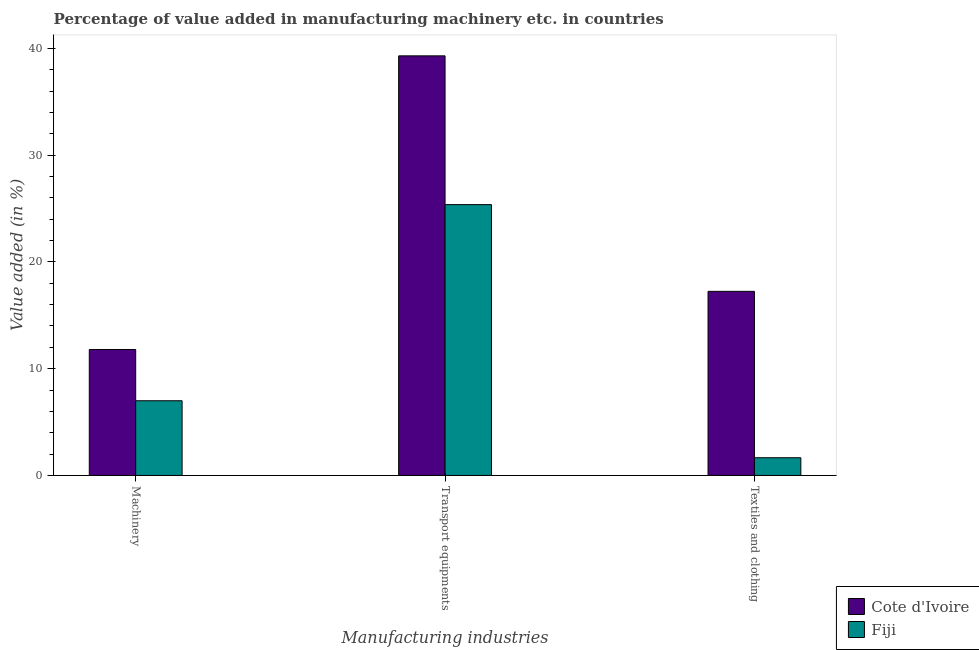Are the number of bars per tick equal to the number of legend labels?
Make the answer very short. Yes. Are the number of bars on each tick of the X-axis equal?
Your response must be concise. Yes. How many bars are there on the 2nd tick from the right?
Your answer should be very brief. 2. What is the label of the 2nd group of bars from the left?
Provide a succinct answer. Transport equipments. What is the value added in manufacturing transport equipments in Fiji?
Your response must be concise. 25.37. Across all countries, what is the maximum value added in manufacturing transport equipments?
Provide a short and direct response. 39.31. Across all countries, what is the minimum value added in manufacturing machinery?
Provide a short and direct response. 7. In which country was the value added in manufacturing textile and clothing maximum?
Give a very brief answer. Cote d'Ivoire. In which country was the value added in manufacturing machinery minimum?
Ensure brevity in your answer.  Fiji. What is the total value added in manufacturing transport equipments in the graph?
Give a very brief answer. 64.67. What is the difference between the value added in manufacturing textile and clothing in Fiji and that in Cote d'Ivoire?
Your answer should be very brief. -15.59. What is the difference between the value added in manufacturing machinery in Cote d'Ivoire and the value added in manufacturing transport equipments in Fiji?
Offer a very short reply. -13.57. What is the average value added in manufacturing transport equipments per country?
Make the answer very short. 32.34. What is the difference between the value added in manufacturing textile and clothing and value added in manufacturing transport equipments in Fiji?
Your answer should be very brief. -23.71. What is the ratio of the value added in manufacturing transport equipments in Cote d'Ivoire to that in Fiji?
Your response must be concise. 1.55. Is the value added in manufacturing transport equipments in Fiji less than that in Cote d'Ivoire?
Keep it short and to the point. Yes. What is the difference between the highest and the second highest value added in manufacturing textile and clothing?
Your answer should be compact. 15.59. What is the difference between the highest and the lowest value added in manufacturing transport equipments?
Ensure brevity in your answer.  13.94. In how many countries, is the value added in manufacturing textile and clothing greater than the average value added in manufacturing textile and clothing taken over all countries?
Offer a terse response. 1. What does the 2nd bar from the left in Transport equipments represents?
Your response must be concise. Fiji. What does the 2nd bar from the right in Machinery represents?
Your answer should be compact. Cote d'Ivoire. Is it the case that in every country, the sum of the value added in manufacturing machinery and value added in manufacturing transport equipments is greater than the value added in manufacturing textile and clothing?
Give a very brief answer. Yes. How many bars are there?
Your response must be concise. 6. Are all the bars in the graph horizontal?
Your answer should be very brief. No. How many countries are there in the graph?
Your answer should be compact. 2. Are the values on the major ticks of Y-axis written in scientific E-notation?
Your answer should be very brief. No. Does the graph contain any zero values?
Offer a very short reply. No. Where does the legend appear in the graph?
Ensure brevity in your answer.  Bottom right. How are the legend labels stacked?
Offer a very short reply. Vertical. What is the title of the graph?
Provide a short and direct response. Percentage of value added in manufacturing machinery etc. in countries. Does "Other small states" appear as one of the legend labels in the graph?
Offer a very short reply. No. What is the label or title of the X-axis?
Make the answer very short. Manufacturing industries. What is the label or title of the Y-axis?
Offer a terse response. Value added (in %). What is the Value added (in %) of Cote d'Ivoire in Machinery?
Provide a short and direct response. 11.8. What is the Value added (in %) of Fiji in Machinery?
Make the answer very short. 7. What is the Value added (in %) in Cote d'Ivoire in Transport equipments?
Provide a short and direct response. 39.31. What is the Value added (in %) of Fiji in Transport equipments?
Give a very brief answer. 25.37. What is the Value added (in %) of Cote d'Ivoire in Textiles and clothing?
Your answer should be very brief. 17.25. What is the Value added (in %) of Fiji in Textiles and clothing?
Your answer should be very brief. 1.66. Across all Manufacturing industries, what is the maximum Value added (in %) in Cote d'Ivoire?
Make the answer very short. 39.31. Across all Manufacturing industries, what is the maximum Value added (in %) in Fiji?
Make the answer very short. 25.37. Across all Manufacturing industries, what is the minimum Value added (in %) of Cote d'Ivoire?
Your response must be concise. 11.8. Across all Manufacturing industries, what is the minimum Value added (in %) in Fiji?
Make the answer very short. 1.66. What is the total Value added (in %) of Cote d'Ivoire in the graph?
Ensure brevity in your answer.  68.35. What is the total Value added (in %) of Fiji in the graph?
Give a very brief answer. 34.02. What is the difference between the Value added (in %) in Cote d'Ivoire in Machinery and that in Transport equipments?
Ensure brevity in your answer.  -27.51. What is the difference between the Value added (in %) in Fiji in Machinery and that in Transport equipments?
Offer a terse response. -18.37. What is the difference between the Value added (in %) in Cote d'Ivoire in Machinery and that in Textiles and clothing?
Offer a very short reply. -5.45. What is the difference between the Value added (in %) of Fiji in Machinery and that in Textiles and clothing?
Your answer should be compact. 5.34. What is the difference between the Value added (in %) in Cote d'Ivoire in Transport equipments and that in Textiles and clothing?
Offer a very short reply. 22.06. What is the difference between the Value added (in %) of Fiji in Transport equipments and that in Textiles and clothing?
Provide a short and direct response. 23.71. What is the difference between the Value added (in %) in Cote d'Ivoire in Machinery and the Value added (in %) in Fiji in Transport equipments?
Keep it short and to the point. -13.57. What is the difference between the Value added (in %) of Cote d'Ivoire in Machinery and the Value added (in %) of Fiji in Textiles and clothing?
Your response must be concise. 10.14. What is the difference between the Value added (in %) of Cote d'Ivoire in Transport equipments and the Value added (in %) of Fiji in Textiles and clothing?
Provide a short and direct response. 37.65. What is the average Value added (in %) in Cote d'Ivoire per Manufacturing industries?
Your response must be concise. 22.78. What is the average Value added (in %) of Fiji per Manufacturing industries?
Ensure brevity in your answer.  11.34. What is the difference between the Value added (in %) in Cote d'Ivoire and Value added (in %) in Fiji in Machinery?
Your answer should be compact. 4.8. What is the difference between the Value added (in %) of Cote d'Ivoire and Value added (in %) of Fiji in Transport equipments?
Offer a very short reply. 13.94. What is the difference between the Value added (in %) of Cote d'Ivoire and Value added (in %) of Fiji in Textiles and clothing?
Offer a terse response. 15.59. What is the ratio of the Value added (in %) of Cote d'Ivoire in Machinery to that in Transport equipments?
Offer a terse response. 0.3. What is the ratio of the Value added (in %) of Fiji in Machinery to that in Transport equipments?
Provide a succinct answer. 0.28. What is the ratio of the Value added (in %) of Cote d'Ivoire in Machinery to that in Textiles and clothing?
Offer a very short reply. 0.68. What is the ratio of the Value added (in %) in Fiji in Machinery to that in Textiles and clothing?
Your answer should be compact. 4.22. What is the ratio of the Value added (in %) in Cote d'Ivoire in Transport equipments to that in Textiles and clothing?
Your answer should be very brief. 2.28. What is the ratio of the Value added (in %) in Fiji in Transport equipments to that in Textiles and clothing?
Keep it short and to the point. 15.31. What is the difference between the highest and the second highest Value added (in %) in Cote d'Ivoire?
Make the answer very short. 22.06. What is the difference between the highest and the second highest Value added (in %) in Fiji?
Your response must be concise. 18.37. What is the difference between the highest and the lowest Value added (in %) in Cote d'Ivoire?
Your answer should be compact. 27.51. What is the difference between the highest and the lowest Value added (in %) in Fiji?
Provide a short and direct response. 23.71. 